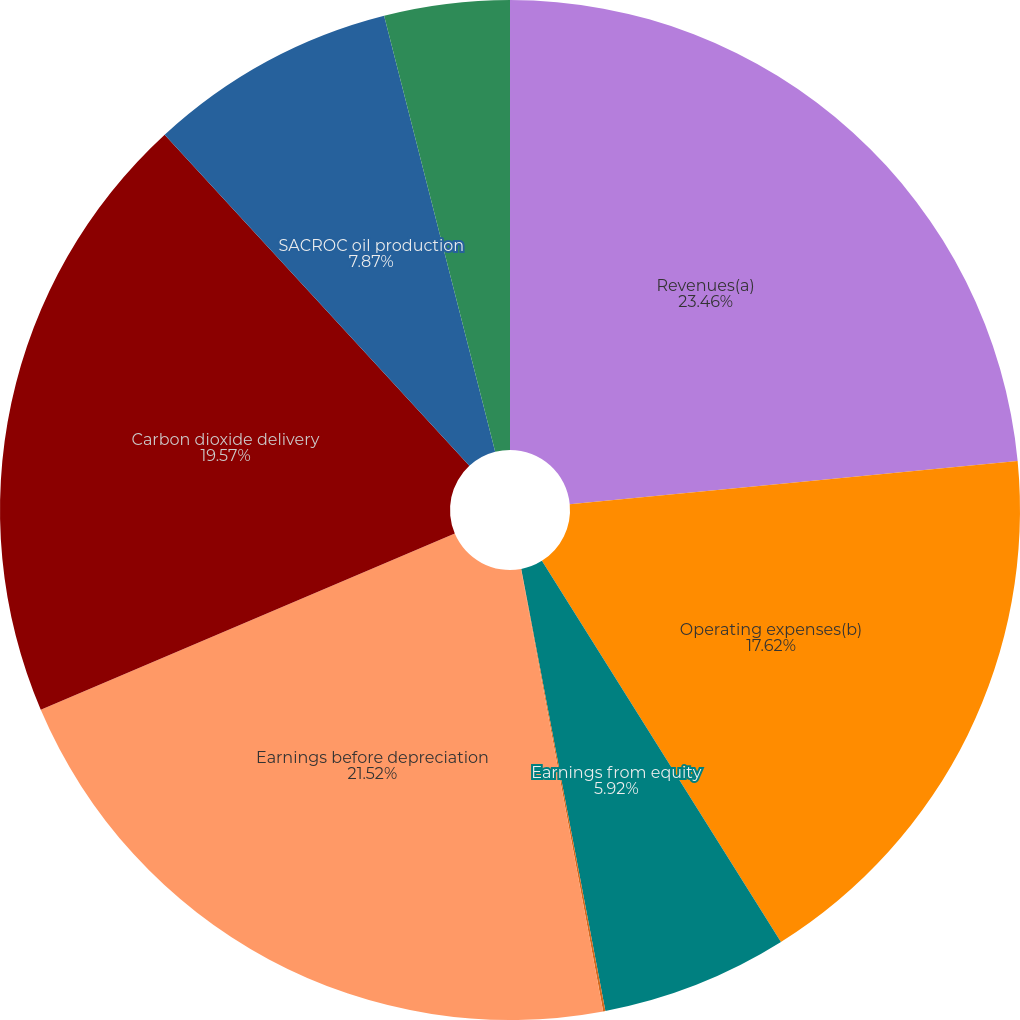<chart> <loc_0><loc_0><loc_500><loc_500><pie_chart><fcel>Revenues(a)<fcel>Operating expenses(b)<fcel>Earnings from equity<fcel>Income tax benefit (expense)<fcel>Earnings before depreciation<fcel>Carbon dioxide delivery<fcel>SACROC oil production<fcel>Yates oil production<nl><fcel>23.47%<fcel>17.62%<fcel>5.92%<fcel>0.07%<fcel>21.52%<fcel>19.57%<fcel>7.87%<fcel>3.97%<nl></chart> 